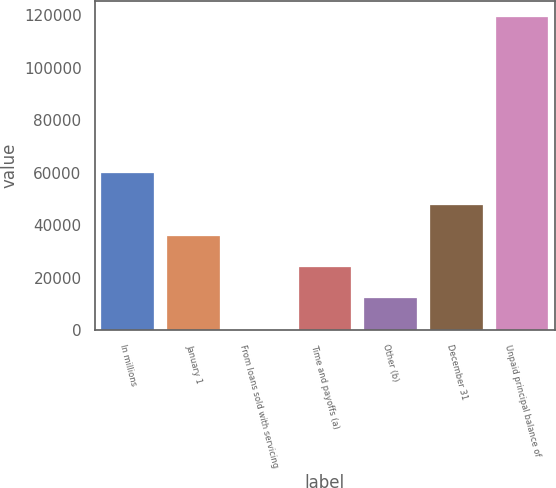Convert chart. <chart><loc_0><loc_0><loc_500><loc_500><bar_chart><fcel>In millions<fcel>January 1<fcel>From loans sold with servicing<fcel>Time and payoffs (a)<fcel>Other (b)<fcel>December 31<fcel>Unpaid principal balance of<nl><fcel>59689.5<fcel>35860.5<fcel>117<fcel>23946<fcel>12031.5<fcel>47775<fcel>119262<nl></chart> 